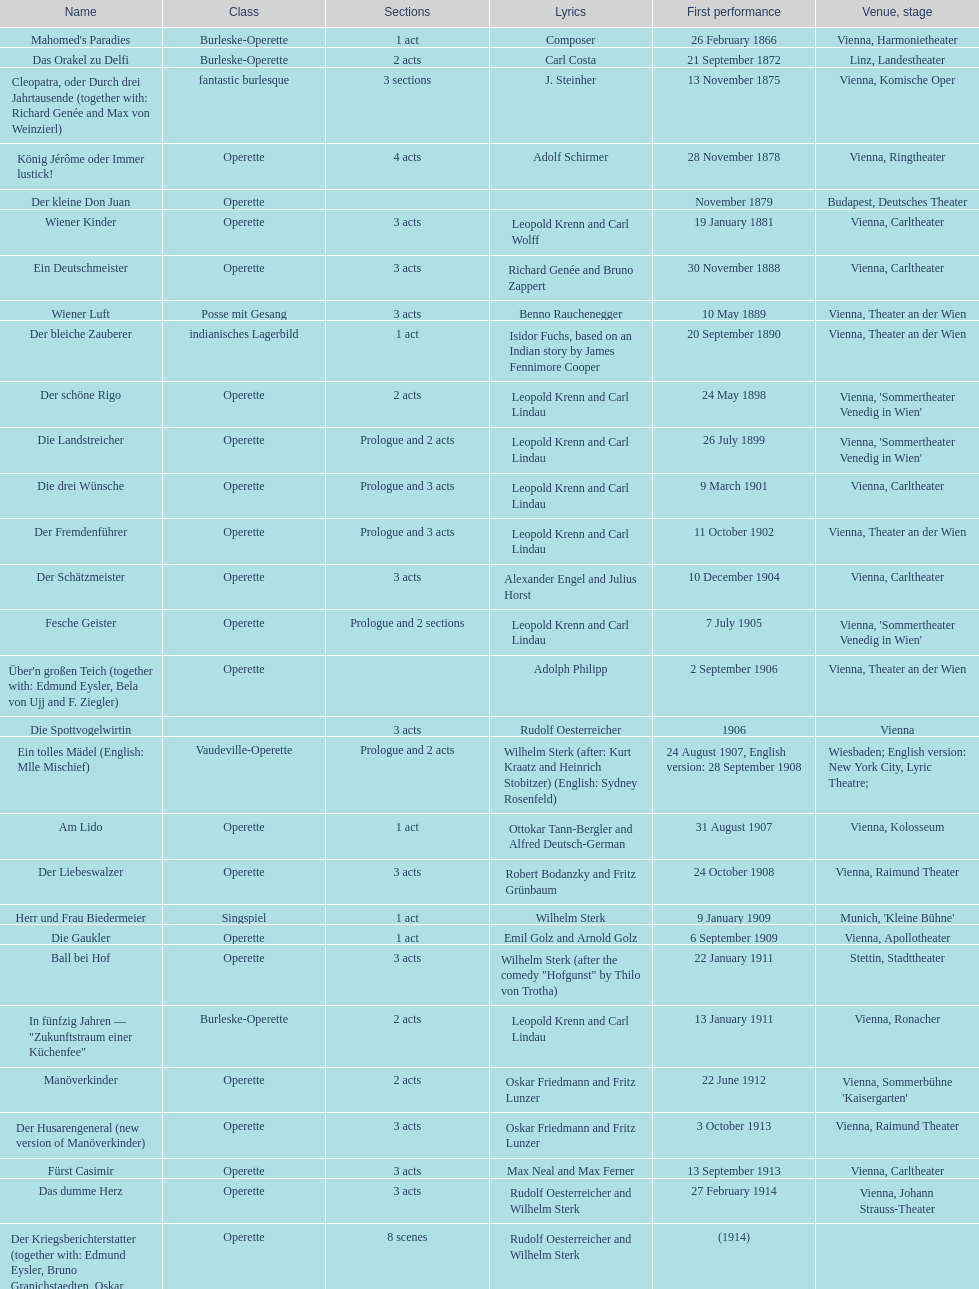Which year did he release his last operetta? 1930. 